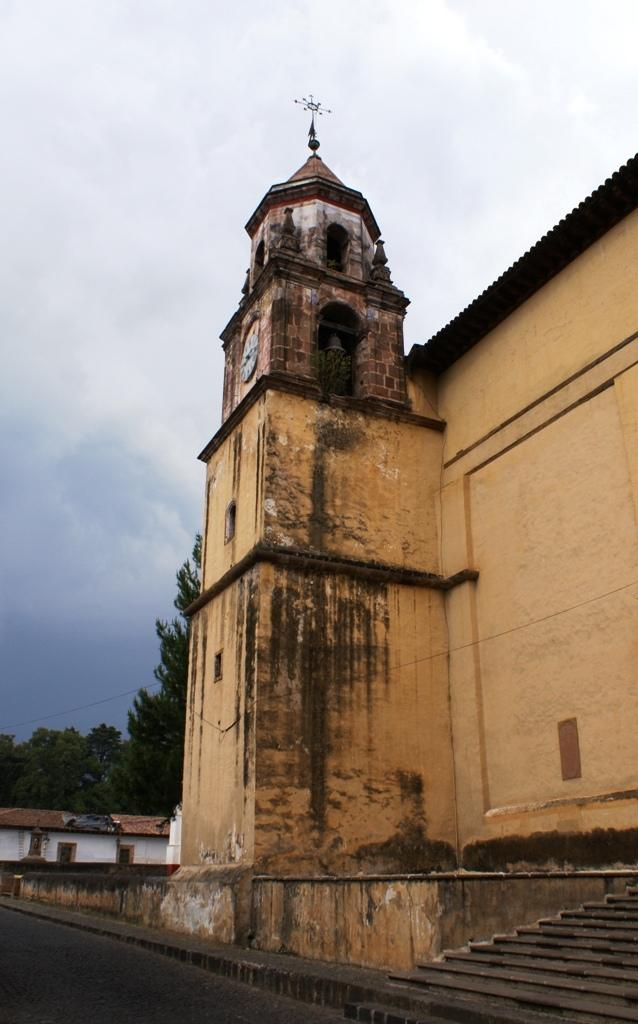What is the main subject in the center of the image? There are buildings in the center of the image. What can be seen in the background of the image? There are trees in the background of the image. How would you describe the sky in the image? The sky is cloudy in the image. What architectural feature is present on the right side of the image? There are steps on the right side of the image. What type of impulse can be seen affecting the buildings in the image? There is no impulse affecting the buildings in the image; they are stationary. Are there any stockings visible on the trees in the image? There are no stockings present on the trees in the image. 